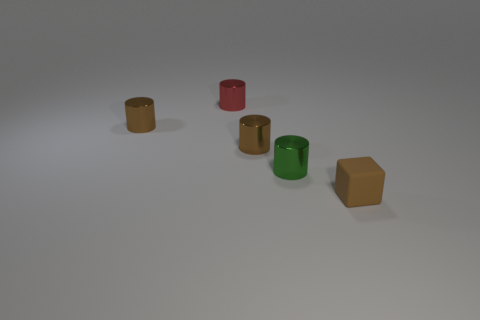Is there anything else that is made of the same material as the small brown cube?
Your answer should be very brief. No. Is the number of tiny red metal things greater than the number of tiny brown cylinders?
Offer a very short reply. No. What number of other things are there of the same material as the red object
Provide a succinct answer. 3. What number of objects are either small metallic cylinders or tiny brown objects that are to the left of the tiny block?
Make the answer very short. 4. Is the number of cylinders less than the number of red shiny cylinders?
Keep it short and to the point. No. There is a tiny rubber thing that is in front of the small brown metallic cylinder in front of the small metallic thing on the left side of the small red metal cylinder; what color is it?
Provide a succinct answer. Brown. Does the green cylinder have the same material as the brown block?
Provide a short and direct response. No. How many red shiny cylinders are right of the green metal cylinder?
Provide a succinct answer. 0. There is a red metal thing that is the same shape as the green shiny object; what size is it?
Keep it short and to the point. Small. How many brown objects are metal cylinders or large shiny objects?
Offer a terse response. 2. 